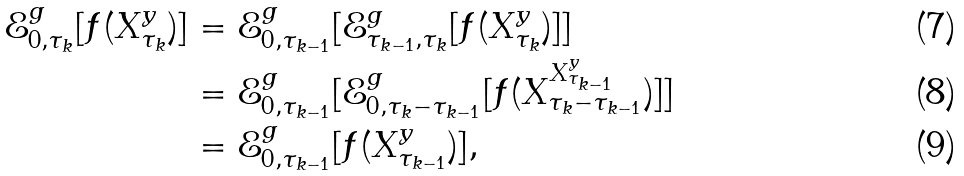<formula> <loc_0><loc_0><loc_500><loc_500>\mathcal { E } ^ { g } _ { 0 , \tau _ { k } } [ f ( X ^ { y } _ { \tau _ { k } } ) ] & = \mathcal { E } ^ { g } _ { 0 , \tau _ { k - 1 } } [ \mathcal { E } ^ { g } _ { \tau _ { k - 1 } , \tau _ { k } } [ f ( X ^ { y } _ { \tau _ { k } } ) ] ] \\ & = \mathcal { E } ^ { g } _ { 0 , \tau _ { k - 1 } } [ \mathcal { E } ^ { g } _ { 0 , \tau _ { k } - \tau _ { k - 1 } } [ f ( X ^ { X ^ { y } _ { \tau _ { k - 1 } } } _ { \tau _ { k } - \tau _ { k - 1 } } ) ] ] \\ & = \mathcal { E } ^ { g } _ { 0 , \tau _ { k - 1 } } [ f ( X ^ { y } _ { \tau _ { k - 1 } } ) ] ,</formula> 